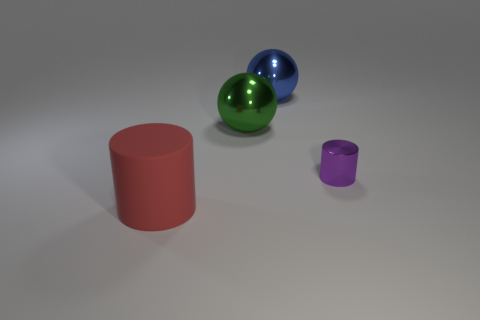Add 4 blue spheres. How many objects exist? 8 Subtract 1 green spheres. How many objects are left? 3 Subtract all large red cubes. Subtract all matte cylinders. How many objects are left? 3 Add 1 green shiny balls. How many green shiny balls are left? 2 Add 2 green metallic blocks. How many green metallic blocks exist? 2 